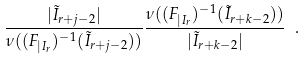Convert formula to latex. <formula><loc_0><loc_0><loc_500><loc_500>\frac { | \tilde { I } _ { r + j - 2 } | } { \nu ( ( F _ { | I _ { r } } ) ^ { - 1 } ( \tilde { I } _ { r + j - 2 } ) ) } \frac { \nu ( ( F _ { | I _ { r } } ) ^ { - 1 } ( \tilde { I } _ { r + k - 2 } ) ) } { | \tilde { I } _ { r + k - 2 } | } \ .</formula> 